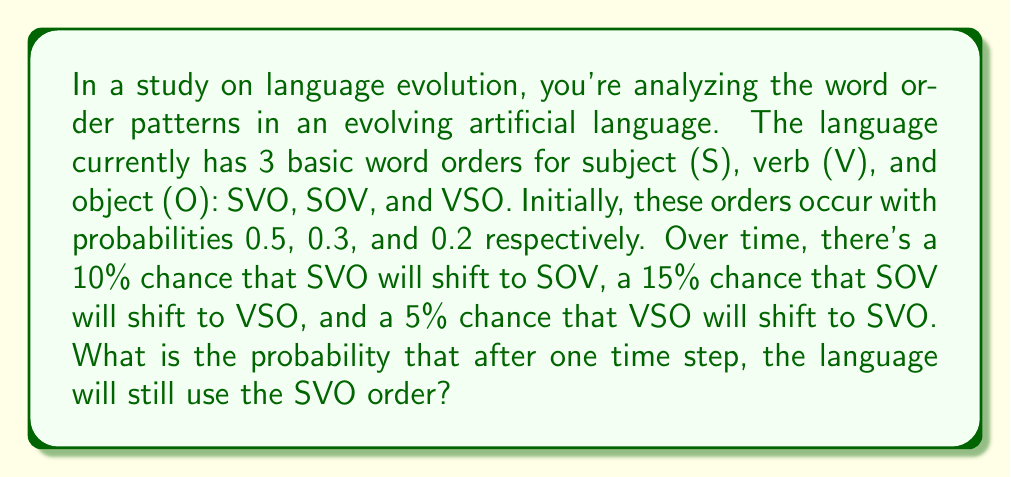Show me your answer to this math problem. Let's approach this step-by-step:

1) First, we need to consider two ways SVO can remain the word order after one time step:
   a) It was SVO initially and didn't change
   b) It was VSO initially and changed to SVO

2) For scenario a):
   - Probability of starting as SVO: 0.5
   - Probability of SVO not changing: 1 - 0.1 = 0.9 (since there's a 10% chance it will shift to SOV)
   - Probability of this scenario: $0.5 \times 0.9 = 0.45$

3) For scenario b):
   - Probability of starting as VSO: 0.2
   - Probability of VSO changing to SVO: 0.05
   - Probability of this scenario: $0.2 \times 0.05 = 0.01$

4) The total probability is the sum of these two scenarios:

   $$P(\text{SVO after one step}) = 0.45 + 0.01 = 0.46$$

Therefore, the probability that the language will still use the SVO order after one time step is 0.46 or 46%.
Answer: 0.46 